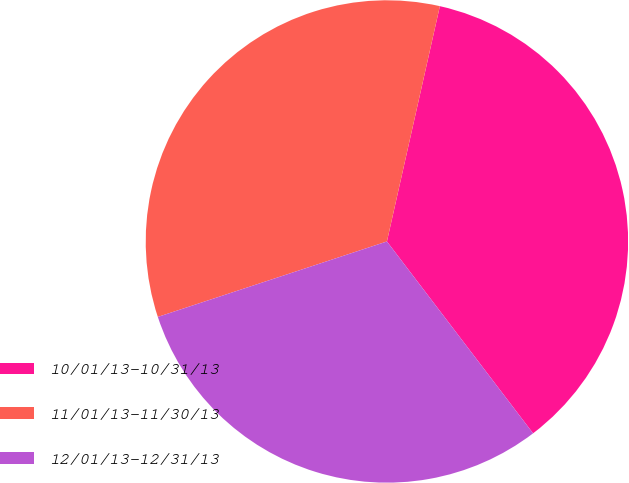<chart> <loc_0><loc_0><loc_500><loc_500><pie_chart><fcel>10/01/13-10/31/13<fcel>11/01/13-11/30/13<fcel>12/01/13-12/31/13<nl><fcel>36.12%<fcel>33.59%<fcel>30.3%<nl></chart> 